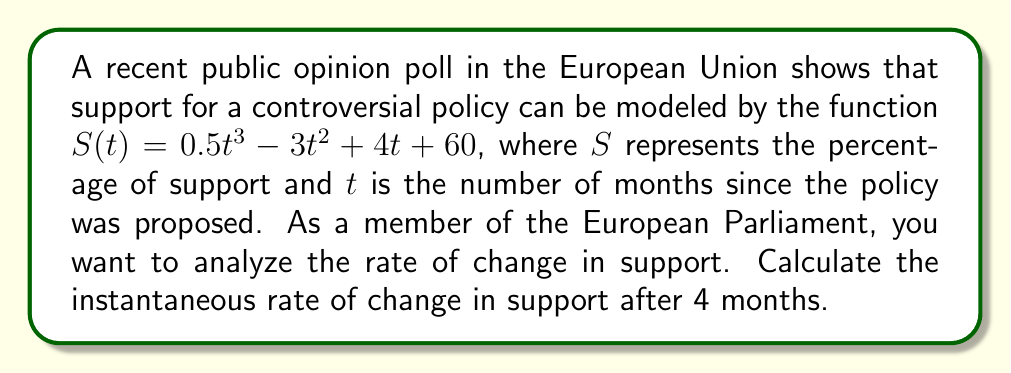Solve this math problem. To find the instantaneous rate of change at $t = 4$, we need to differentiate $S(t)$ and then evaluate it at $t = 4$.

Step 1: Differentiate $S(t)$
$$\frac{d}{dt}S(t) = \frac{d}{dt}(0.5t^3 - 3t^2 + 4t + 60)$$
$$S'(t) = 1.5t^2 - 6t + 4$$

Step 2: Evaluate $S'(t)$ at $t = 4$
$$S'(4) = 1.5(4)^2 - 6(4) + 4$$
$$S'(4) = 1.5(16) - 24 + 4$$
$$S'(4) = 24 - 24 + 4$$
$$S'(4) = 4$$

Therefore, the instantaneous rate of change in support after 4 months is 4 percentage points per month.
Answer: 4 percentage points per month 